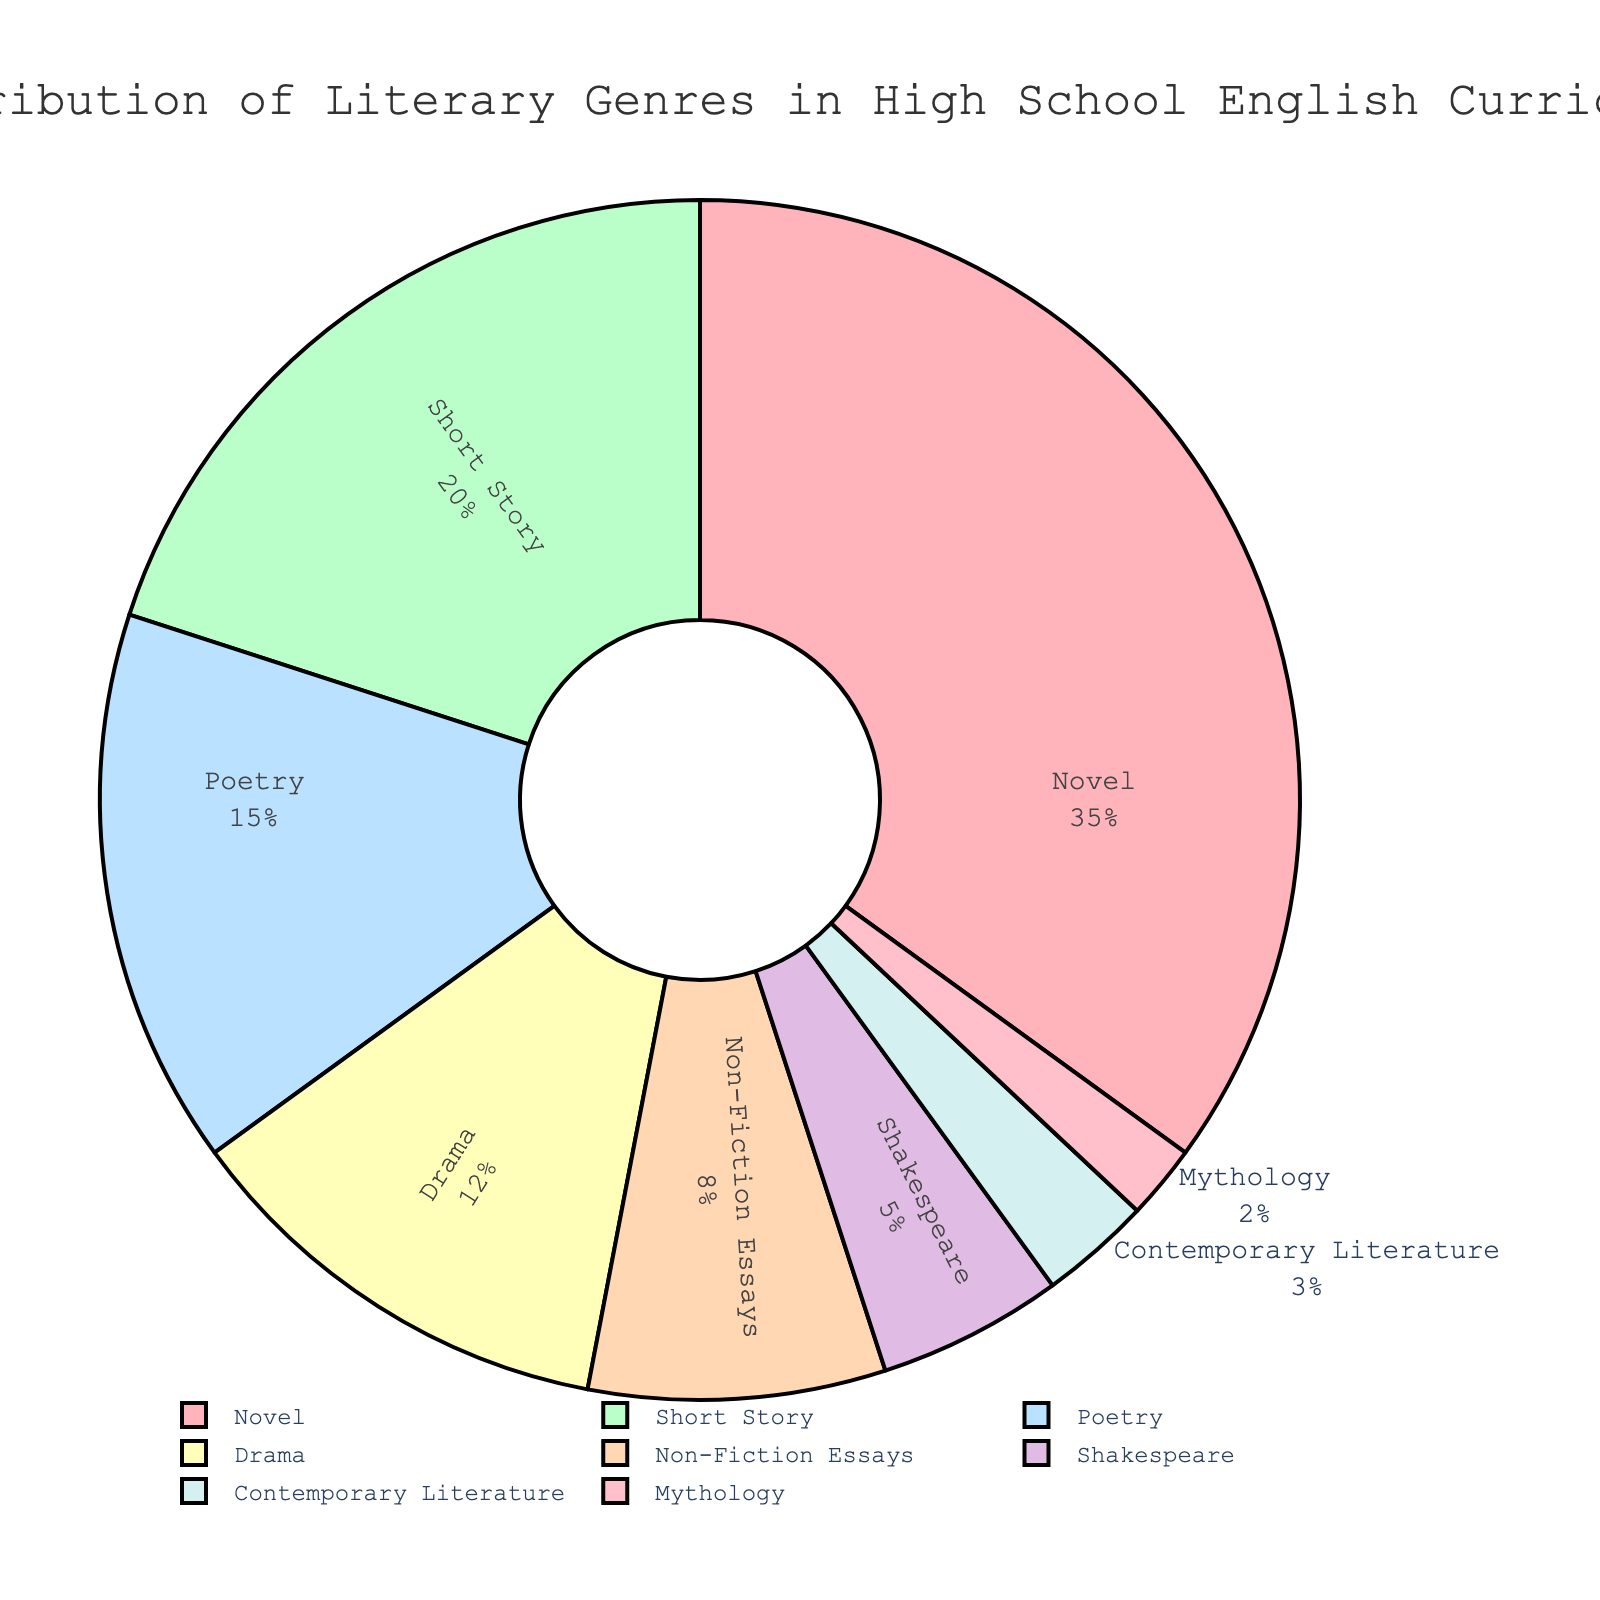What genre occupies the largest proportion in the high school English curriculum pie chart? By looking at the figure, observe which section of the pie chart is the largest. The pie chart indicates that "Novel" occupies the largest proportion at 35%.
Answer: Novel Which two genres together make up the smallest proportion in the curriculum? To determine this, find the two smallest sections in the pie chart. "Mythology" (2%) and "Contemporary Literature" (3%) are the smallest, together making up 5%.
Answer: Mythology and Contemporary Literature How many genres have a percentage greater than or equal to 10%? Examine the figure and count the sections with percentages 10% or more: "Novel" (35%), "Short Story" (20%), "Poetry" (15%), and "Drama" (12%) — totaling 4 genres.
Answer: 4 Which genre has a smaller proportion than Non-Fiction Essays but larger than Shakespeare? First, identify the percentages for Non-Fiction Essays (8%) and Shakespeare (5%). "Drama" (12%) and "Poetry" (15%) have higher proportions than Non-Fiction Essays. Out of these options, "Poetry" is within the range.
Answer: Poetry What is the combined percentage of Non-Fiction Essays and Drama? Add the percentages of Non-Fiction Essays (8%) and Drama (12%). 8 + 12 = 20%
Answer: 20% Which genre has the smallest representation, and what is its percentage? In the chart, the smallest section represents "Mythology," with a percentage of 2%.
Answer: Mythology, 2% How does the percentage of Short Stories compare to that of Poetry? Short Stories have a percentage of 20%, while Poetry has 15%. Thus, Short Stories have a higher percentage.
Answer: Short Stories have a higher percentage than Poetry If we combine the percentages of Contemporary Literature and Shakespeare, what portion of the curriculum does this represent? Sum the percentages of Contemporary Literature (3%) and Shakespeare (5%). 3 + 5 = 8%
Answer: 8% What is the total percentage represented by Novel, Short Story, and Poetry combined? Add the percentages of Novel (35%), Short Story (20%), and Poetry (15%). 35 + 20 + 15 = 70%
Answer: 70% How does Mythology compare to the next smallest genre in the pie chart? The smallest genre, Mythology, is at 2%. The next smallest, Contemporary Literature, is at 3%. So, Mythology is 1% less.
Answer: Mythology is 1% less than Contemporary Literature 